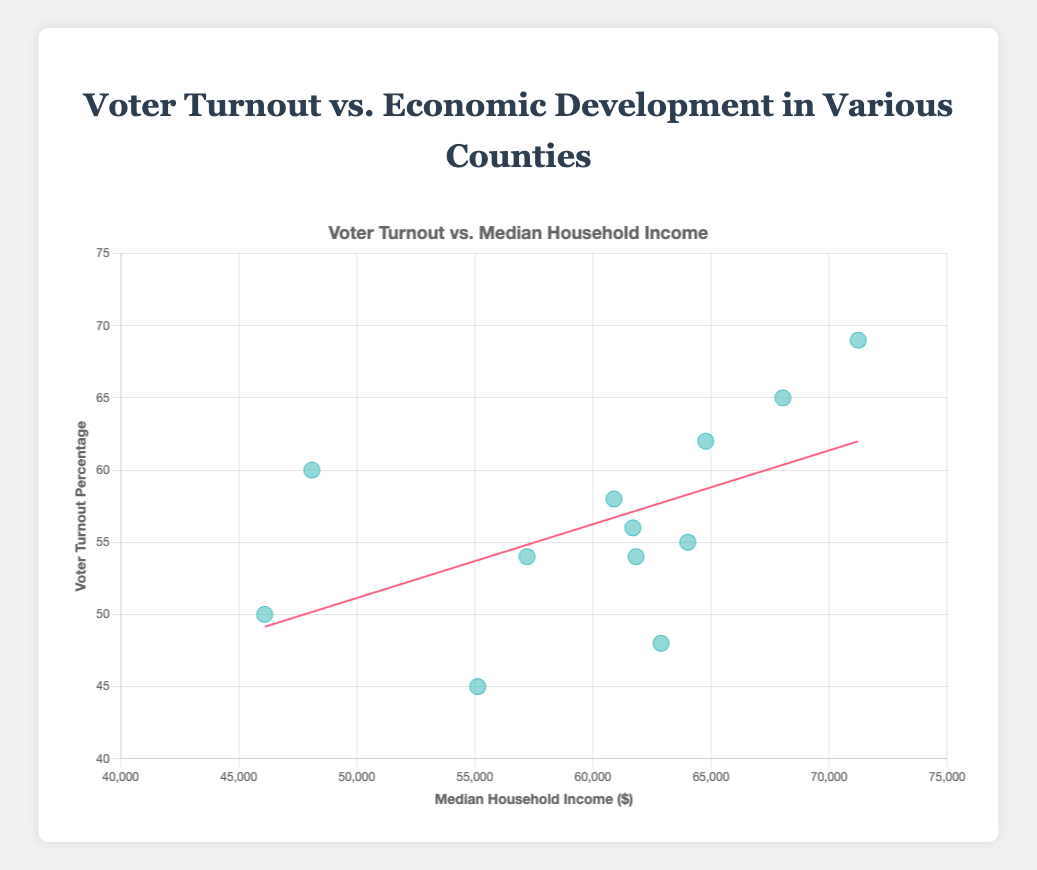How many counties are represented in the scatter plot? By counting the number of distinct data points on the scatter plot, we can determine the number of counties represented.
Answer: 12 What is the general trend between voter turnout and median household income as indicated by the trend line? Observing the slope of the trend line, if it is positive, it indicates that as median household income increases, voter turnout also tends to increase. If it is negative, voter turnout tends to decrease as median household income increases.
Answer: Positive correlation Which county has the highest voter turnout and what is its median household income? Look for the highest point on the y-axis (voter turnout percentage) and find its corresponding x-value (median household income). The tooltip from the scatter plot can provide additional detail including the county name.
Answer: San Diego County, $71,235 What is the difference in median household income between the county with the highest and the lowest voter turnout? Identify the counties with the highest and lowest voter turnout percentages. San Diego County has the highest (69%) and Clark County has the lowest (45%). Subtract the median household incomes of these counties: $71,235 - $55,120.
Answer: $16,115 Which state has the most counties represented on the scatter plot? Count how many data points belong to each state by observing the tooltip that appears on the scatter plot. Texas and California have three counties each.
Answer: California and Texas Is there a county with a voter turnout below 50% but a median household income above $60,000? Check all data points below 50% on the y-axis and identify if any of them fall to the right of the $60,000 mark on the x-axis. Kings County has 48% voter turnout and a median household income of $62,885.
Answer: Yes, Kings County Compare the voter turnout percentages of the counties with median household incomes closest to $60,000 and $70,000. Which one is higher? Find Harris County (closest to $60,000) with a voter turnout of 58%, and San Diego County (closest to $70,000) with a voter turnout of 69%. Compare the two voter turnout values.
Answer: San Diego County, 69% What does the tooltip display when you hover over a data point in the scatter plot? The tooltip shows the county name, state name, voter turnout percentage, and median household income for each data point when hovered.
Answer: County, State, Voter Turnout %, Median Household Income Does Miami-Dade County have a higher or lower median household income compared to Harris County? Compare the x-axis values for Miami-Dade County ($48,100) and Harris County ($60,893).
Answer: Lower 